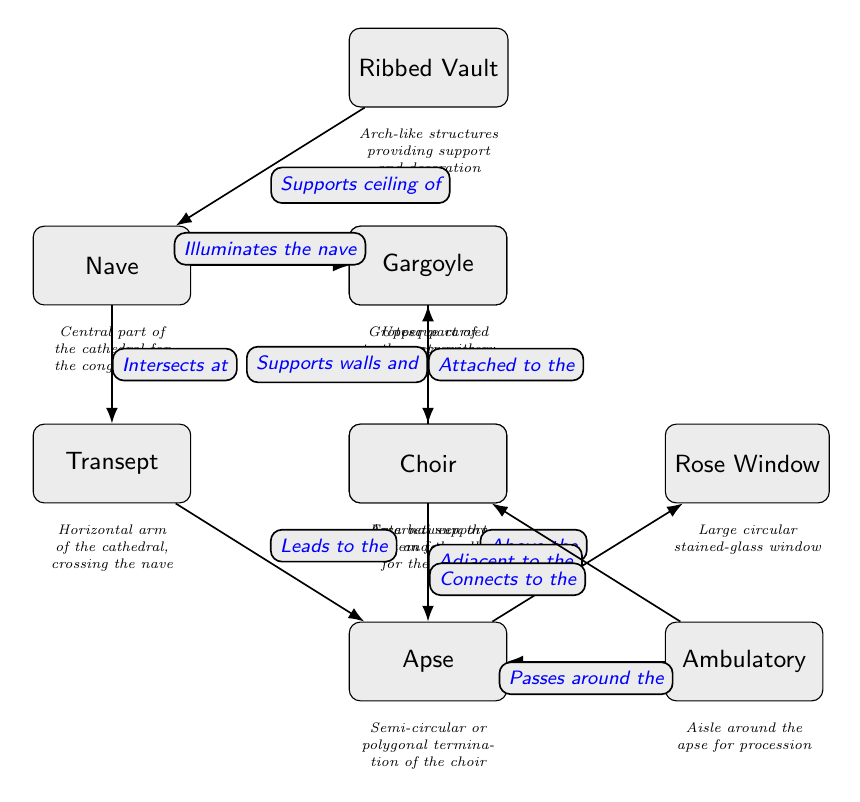What is the central part of the cathedral called? The diagram indicates that the central part of the cathedral, where the congregation gathers, is labeled as "Nave."
Answer: Nave How many architectural features are depicted in the diagram? By counting each of the nodes labeled in the diagram, there are ten features represented, including nave, flying buttress, ribbed vault, clerestory, transept, apse, rose window, gargoyle, ambulatory, and choir.
Answer: 10 What role does the clerestory play in the nave? The diagram shows an edge labeled "Illuminates the nave" indicating that the clerestory, which is part of the upper section of the nave, allows light into the nave.
Answer: Illuminates the nave What feature is directly above the apse? The relationship shown in the diagram indicates that the "Rose Window" is positioned directly above the "Apse," as there is an edge that points upward from apse to rose window.
Answer: Rose Window Which feature supports the walls and clerestory? The diagram illustrates that the "Flying Buttress" supports both the walls and the clerestory, as indicated by the connection line labeled "Supports walls and" pointing towards the clerestory.
Answer: Flying Buttress How is the transept associated with the nave? According to the diagram, the transept intersects with the nave, as indicated by the connection labeled "Intersects at," which shows their relationship.
Answer: Intersects at What does the gargoyle do? The diagram states that gargoyles are "Attached to the flying" buttress and serve as water spouts, as understood from the description associated with the gargoyle in the diagram.
Answer: Water spouts What is the connection between the ambulatory and the choir? The diagram displays two edges connected to the ambulatory; one labeled "Passes around the" apse indicates its surrounding role and another labeled "Connects to the" choir shows direct passage to the choir.
Answer: Connects to the choir What primary function does the ribbed vault serve? The diagram includes a description stating that the ribbed vault supports the ceiling of the nave, illustrating its structural importance in cathedral architecture.
Answer: Supports ceiling of nave 